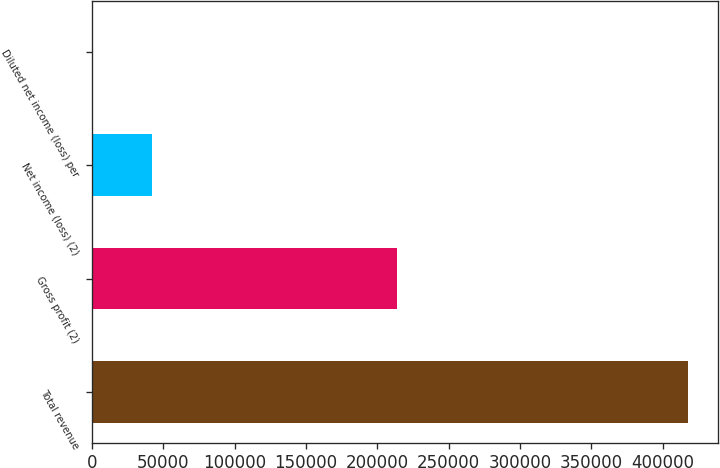<chart> <loc_0><loc_0><loc_500><loc_500><bar_chart><fcel>Total revenue<fcel>Gross profit (2)<fcel>Net income (loss) (2)<fcel>Diluted net income (loss) per<nl><fcel>418112<fcel>213639<fcel>41811.3<fcel>0.08<nl></chart> 